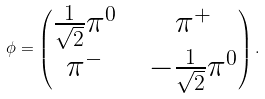Convert formula to latex. <formula><loc_0><loc_0><loc_500><loc_500>\phi = \begin{pmatrix} \frac { 1 } { \sqrt { 2 } } \pi ^ { 0 } & & \pi ^ { + } \\ \pi ^ { - } & & - \frac { 1 } { \sqrt { 2 } } \pi ^ { 0 } \end{pmatrix} .</formula> 